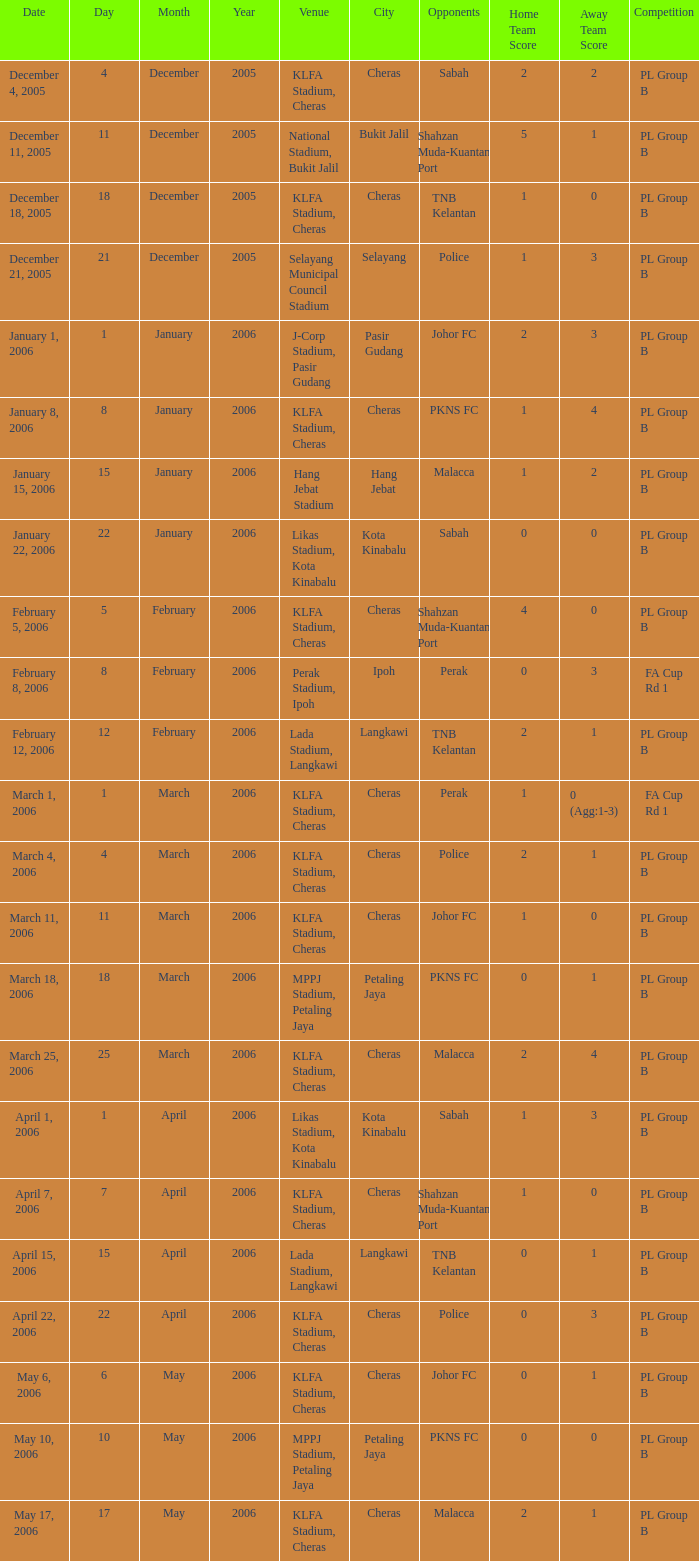Which Competition has a Score of 0-1, and Opponents of pkns fc? PL Group B. 